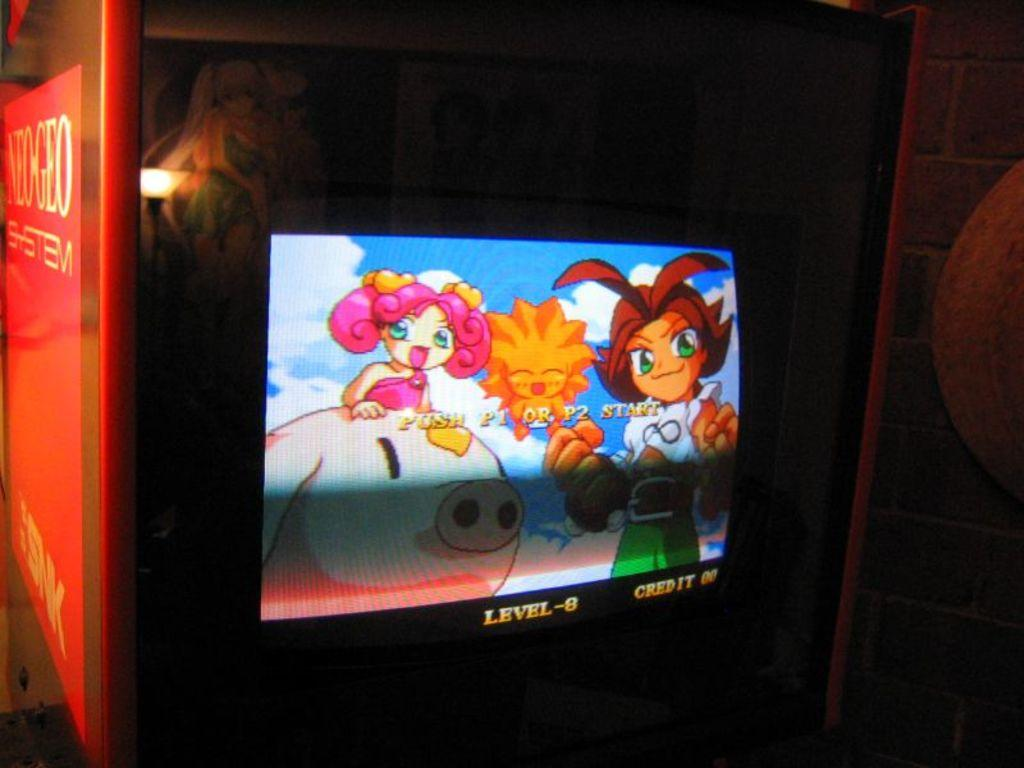<image>
Provide a brief description of the given image. An arcade game says PUSH P1 OR P2 START on the screen. 